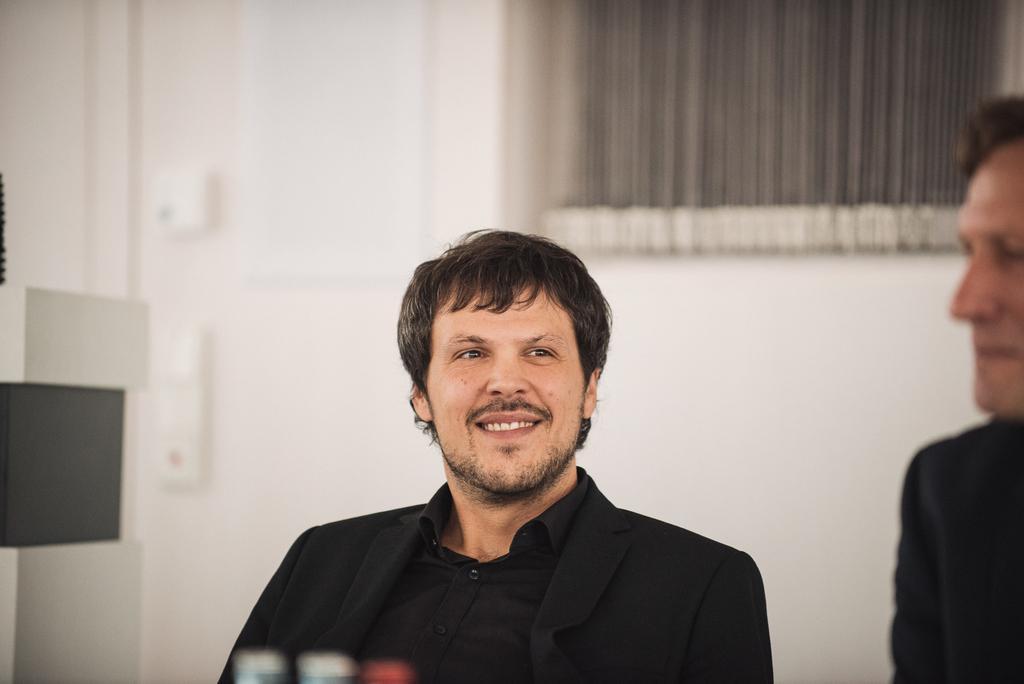In one or two sentences, can you explain what this image depicts? In this image in the front there are persons. In the background there is a wall and there is a window and on the wall there are objects which are white in colour. On the left side there is a table which is white and black in colour. 